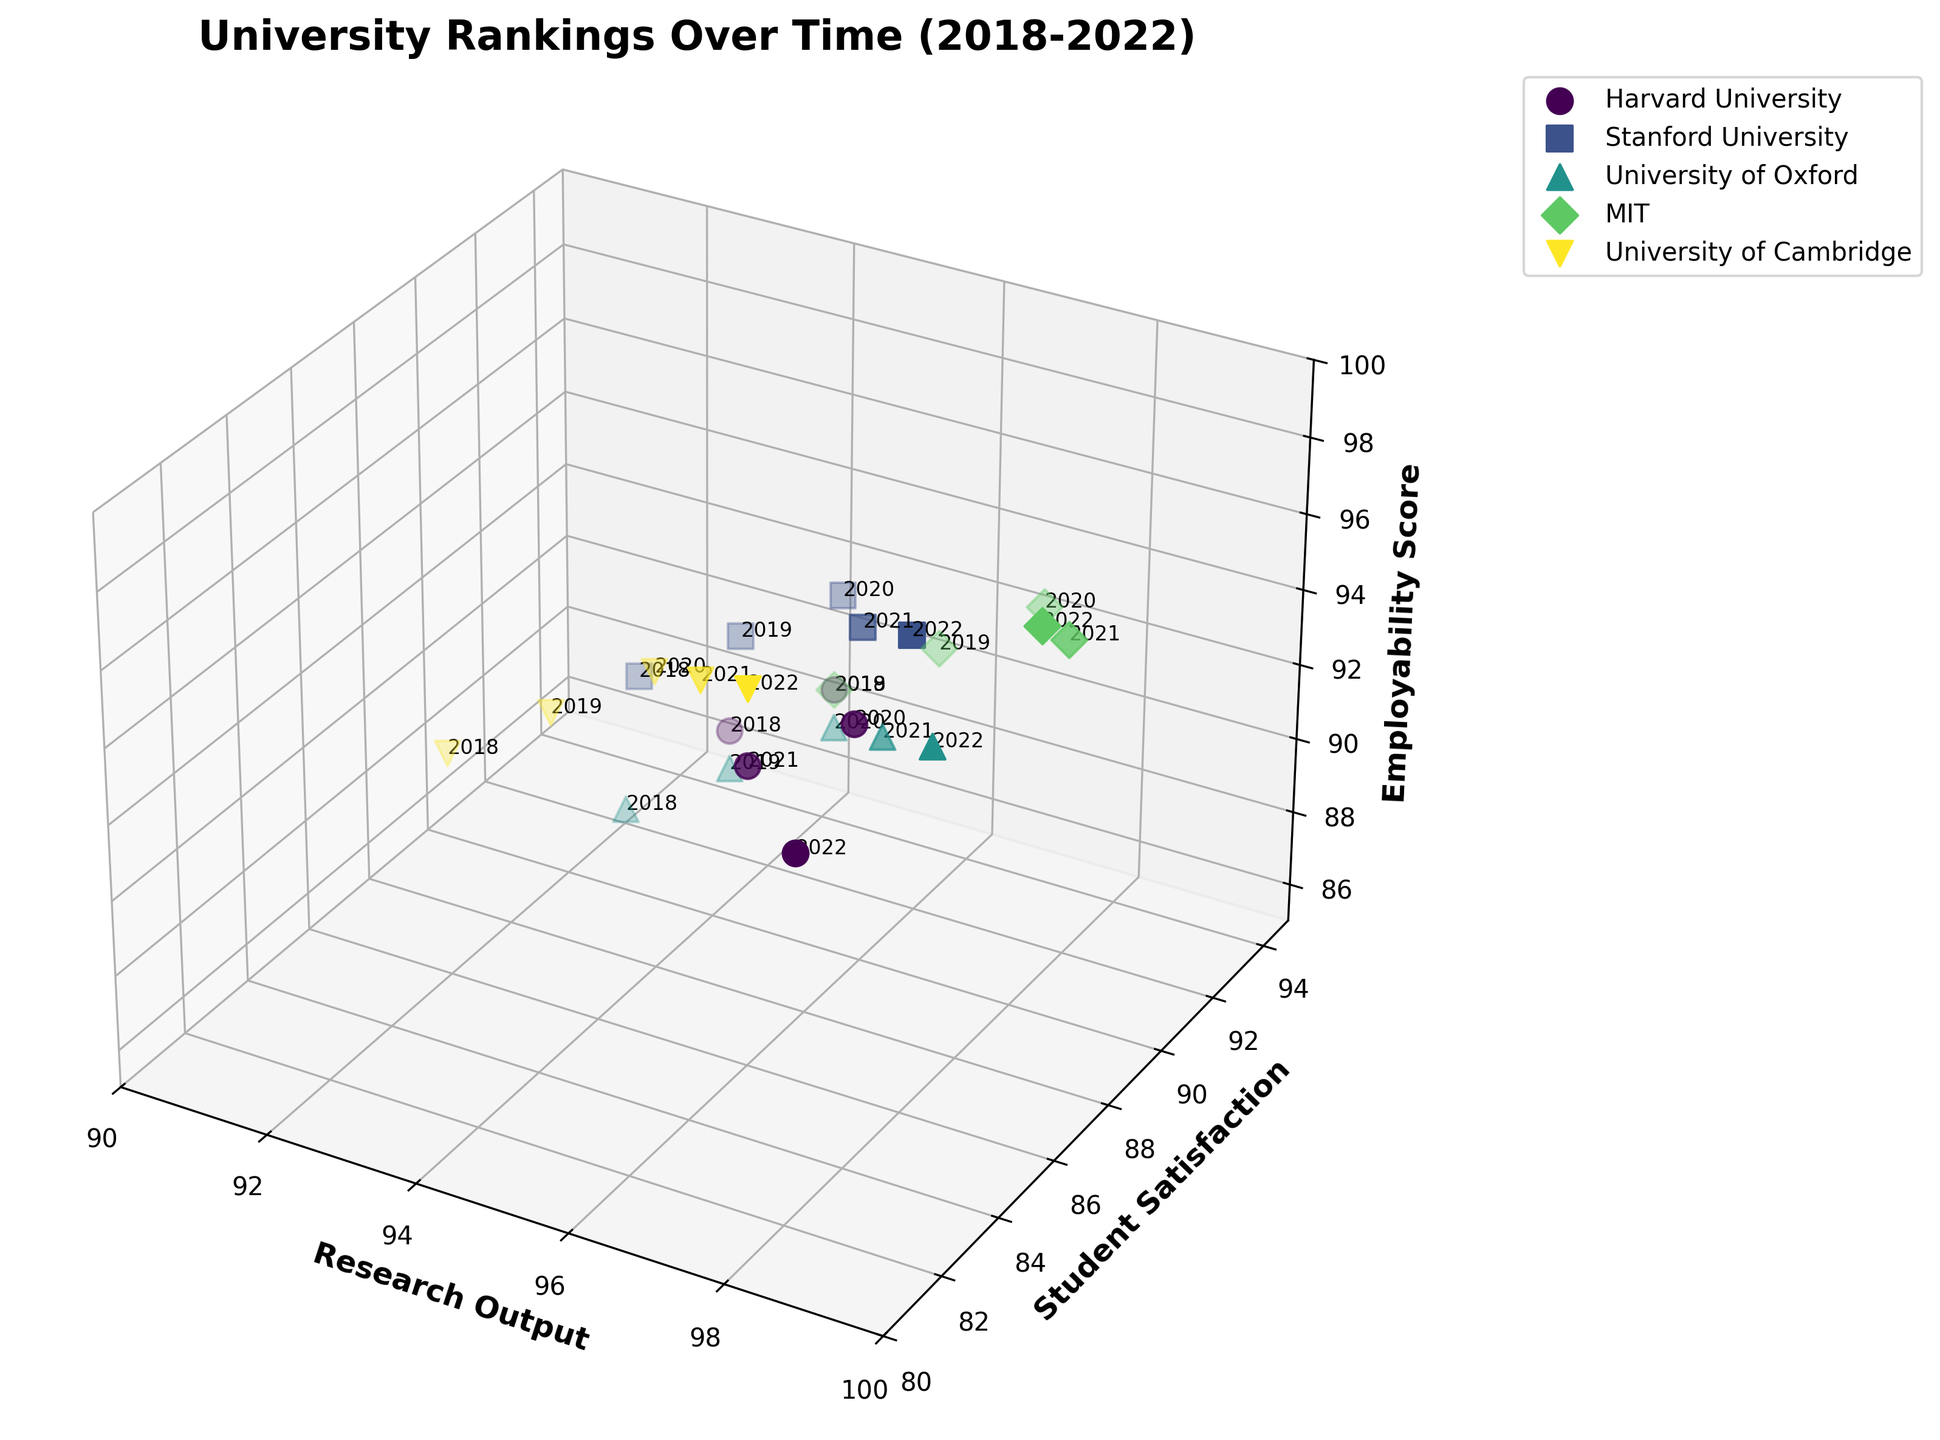How many universities are represented in the plot? Look at the number of unique legend entries for the universities displayed. Each marker and color combination represents a unique university.
Answer: 5 Which university has the highest Research Output score in 2022? Identify the data point for the year 2022 along the Research Output axis, then check the corresponding university label for the highest score.
Answer: MIT What is the range of Employability Scores for Stanford University over the years? Examine the z-axis values for the data points representing Stanford University and identify the minimum and maximum scores.
Answer: 91 to 95 How did the Student Satisfaction score for Harvard University change from 2018 to 2022? Compare the y-axis values for Harvard University data points for the years 2018 and 2022.
Answer: Decreased from 88 to 85 What is the difference in Research Output between MIT and University of Cambridge in 2021? Identify the Research Output values for MIT and University of Cambridge in 2021, then compute the difference between the two values.
Answer: 4 Which university shows the most consistent (least variable) Employability Score over the years? Compare the Employability Score ranges for all universities by looking at the spread of data points along the z-axis for each university.
Answer: Harvard University Between 2018 and 2022, which university showed the most improvement in Student Satisfaction? Determine the change in Student Satisfaction scores for each university from 2018 to 2022 and compare their increments.
Answer: Stanford University What is the highest Student Satisfaction score observed in the plot, and which university achieved it? Find the maximum y-axis value in the plot and check the corresponding university label.
Answer: Stanford University in 2020 How does the Student Satisfaction score of MIT in 2018 compare to its score in 2022? Check the y-axis values for MIT for the years 2018 and 2022 and compare them.
Answer: Decreased from 89 to 88 